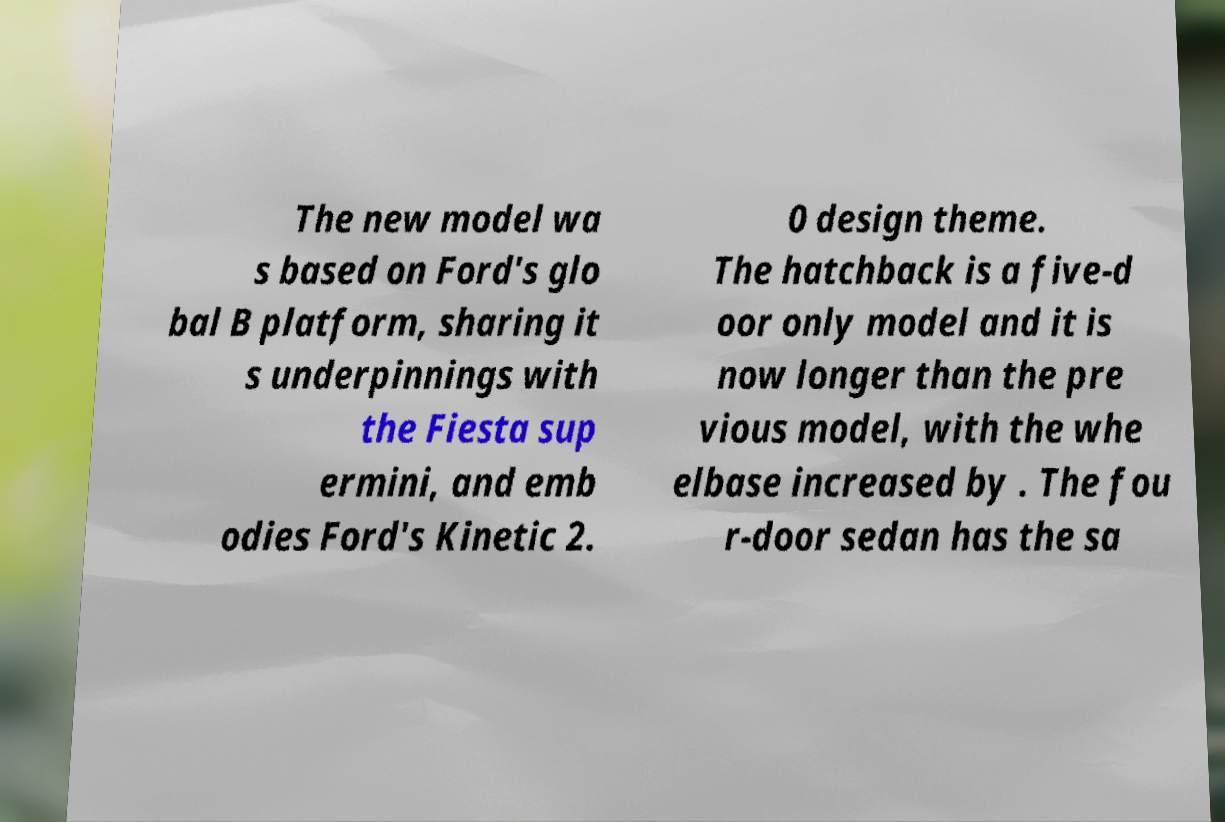Please identify and transcribe the text found in this image. The new model wa s based on Ford's glo bal B platform, sharing it s underpinnings with the Fiesta sup ermini, and emb odies Ford's Kinetic 2. 0 design theme. The hatchback is a five-d oor only model and it is now longer than the pre vious model, with the whe elbase increased by . The fou r-door sedan has the sa 